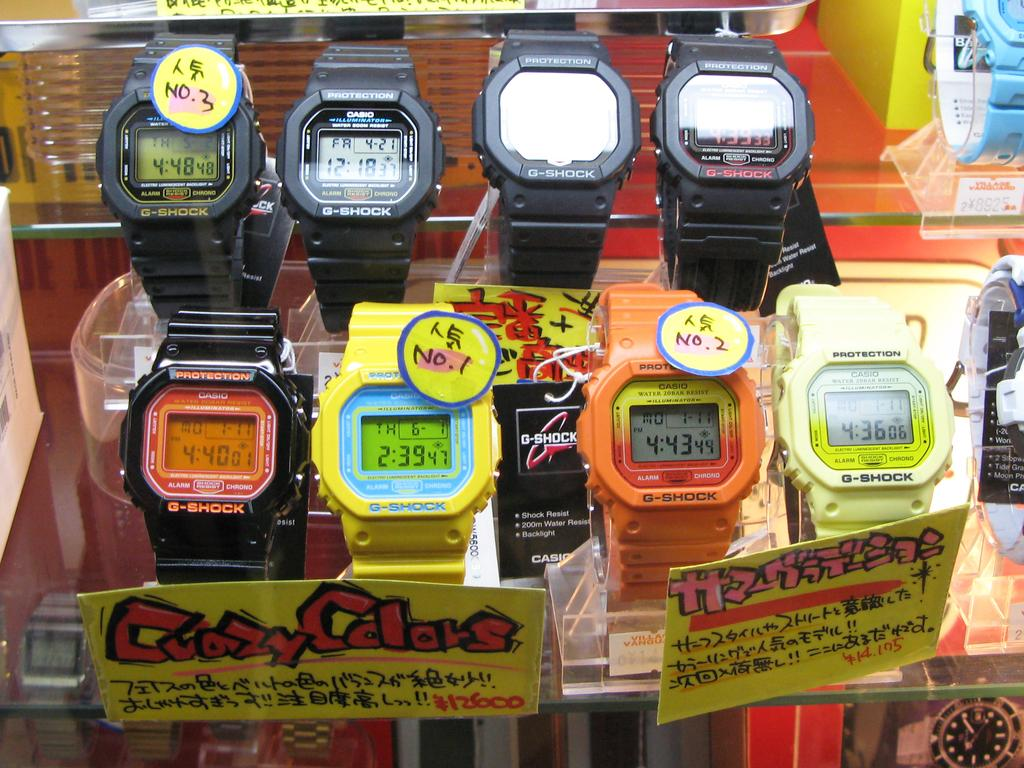<image>
Summarize the visual content of the image. display of colorful casio digital watches with crazycolors sign in front of them 